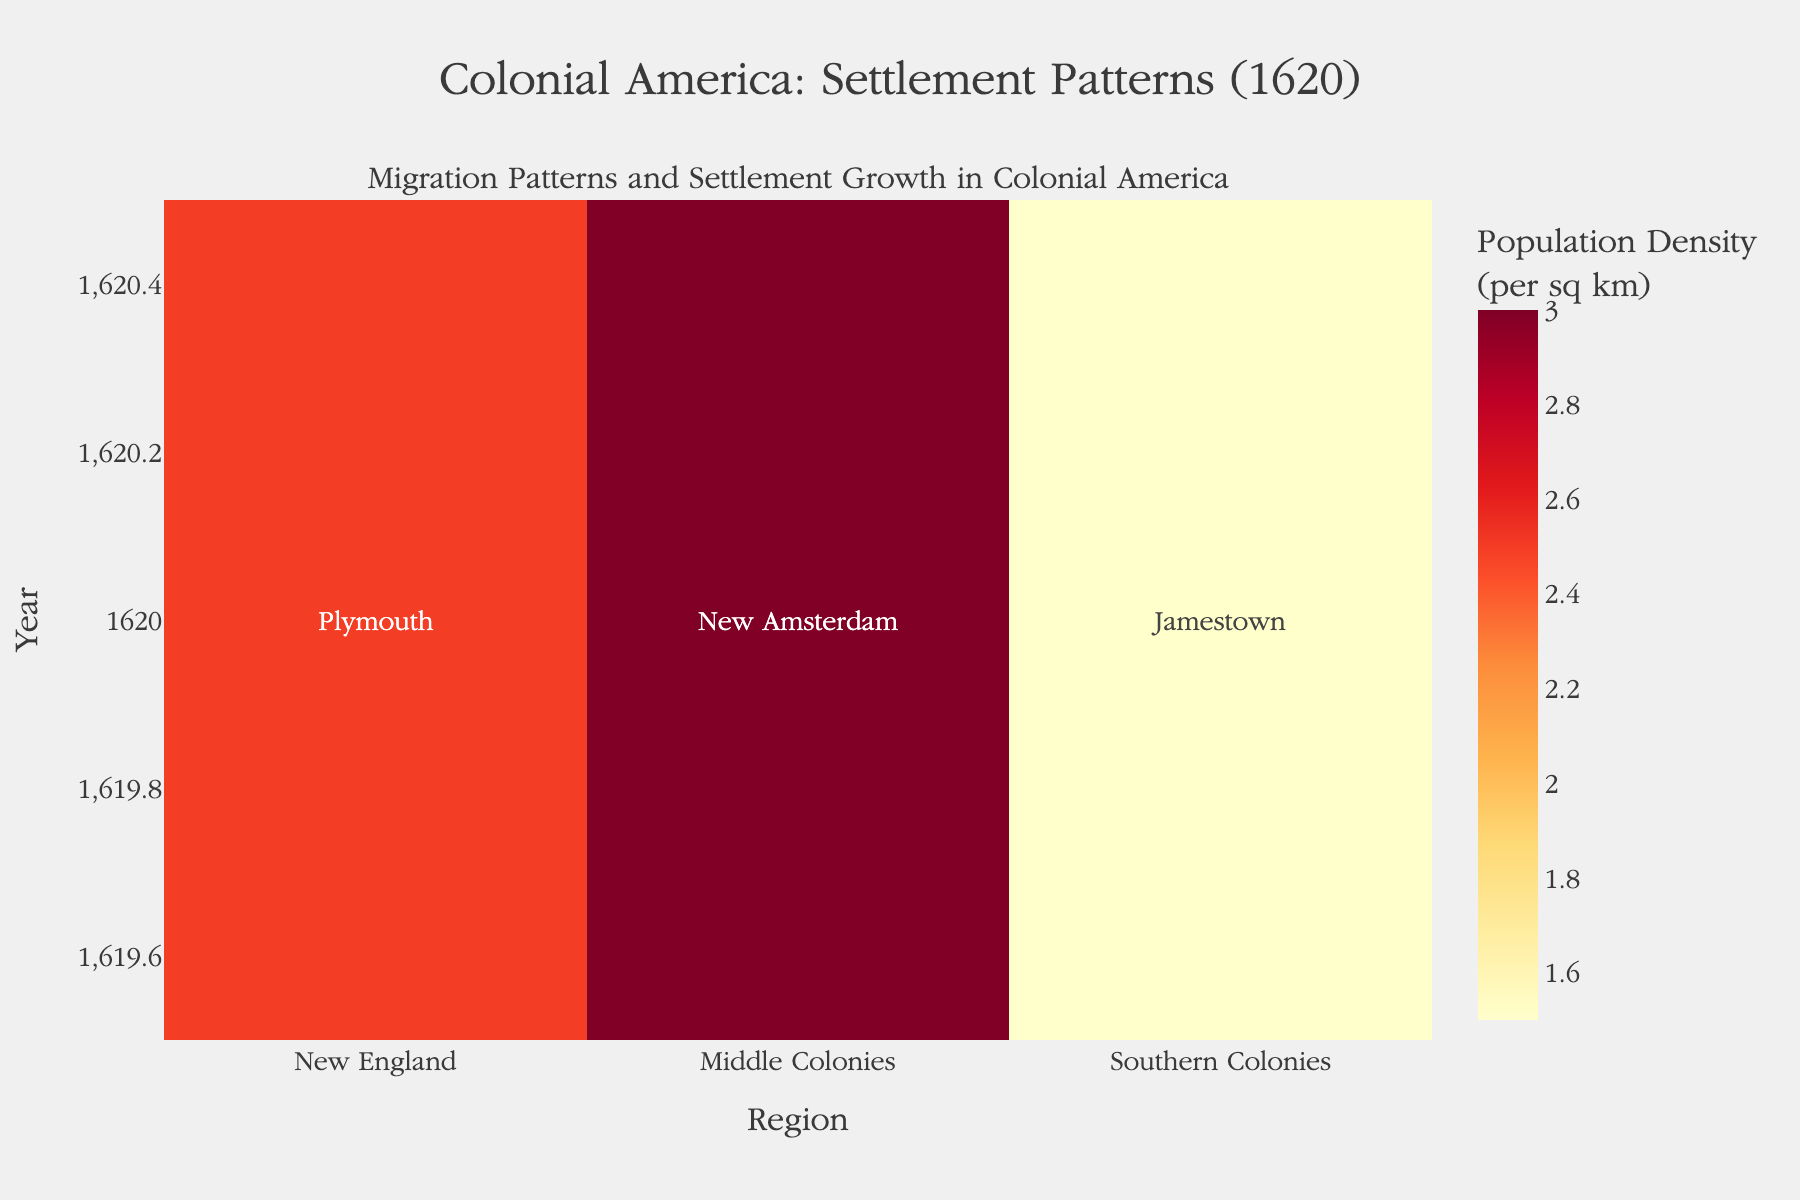What's the title of the heatmap figure? The title of the figure is displayed prominently at the top of the heatmap in a large and bold font. It reads "Colonial America: Settlement Patterns (1620)"
Answer: Colonial America: Settlement Patterns (1620) What year is depicted in the heatmap for migration patterns and settlement growth? The year is consistently labeled on the Y-axis of the heatmap as well as mentioned in the title.
Answer: 1620 Which region had the highest population density in 1620? On the heatmap, the population density values are displayed using a color gradient where higher densities use warmer colors like red or orange. Among "New England", "Middle Colonies", and "Southern Colonies", the region with the warmest color, and also the explicitly labeled highest number (3.0), is "Middle Colonies".
Answer: Middle Colonies What is the name of the major settlement in New England according to the heatmap? The heatmap uses text annotations to show the names of major settlements. For New England, the text annotation displays the settlement name "Plymouth".
Answer: Plymouth Which region had the lowest population density in 1620, and what was the density? By looking at the color gradient and the labeled values, we see that the region with the lowest population density is "Southern Colonies", denoted by the color corresponding to the value 1.5.
Answer: Southern Colonies, 1.5 Compare the population densities of New England and the Southern Colonies. Which one is higher and by how much? New England has a population density of 2.5, while the Southern Colonies have a population density of 1.5. Subtracting these values, 2.5 - 1.5 gives us the difference.
Answer: New England; 1.0 higher What is the total number of regions represented in the heatmap? We count the unique labels on the X-axis. The heatmap shows three distinct regions: "New England", "Middle Colonies", and "Southern Colonies".
Answer: 3 What is the range of population densities shown in the heatmap? We identify the minimum and maximum values of population densities provided for the regions. The minimum value is 1.5 (Southern Colonies) and the maximum value is 3.0 (Middle Colonies). The range is calculated as the maximum minus the minimum, 3.0 - 1.5.
Answer: 1.5 How does the population density of the Middle Colonies compare visually with the other regions? Visually, the Middle Colonies use a warmer color (orange-red) compared to the other regions, indicating a higher population density. By numerical value, 3.0 is higher than both 2.5 (New England) and 1.5 (Southern Colonies).
Answer: Higher How is the color gradient used to represent different population densities, and what colors indicate higher and lower densities? The heatmap uses a color gradient from the YlOrRd scale, where lighter colors (yellow) represent lower densities and darker/redder colors represent higher densities.
Answer: Yellow for lower, red for higher densities 